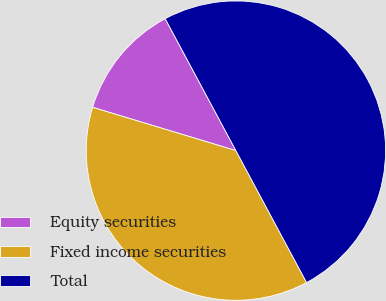<chart> <loc_0><loc_0><loc_500><loc_500><pie_chart><fcel>Equity securities<fcel>Fixed income securities<fcel>Total<nl><fcel>12.5%<fcel>37.5%<fcel>50.0%<nl></chart> 